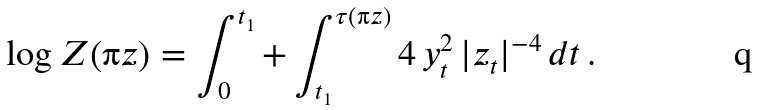Convert formula to latex. <formula><loc_0><loc_0><loc_500><loc_500>\log Z ( \i z ) = \int _ { 0 } ^ { t _ { 1 } } + \int _ { t _ { 1 } } ^ { \tau ( \i z ) } 4 \, y _ { t } ^ { 2 } \, | z _ { t } | ^ { - 4 } \, d t \, .</formula> 